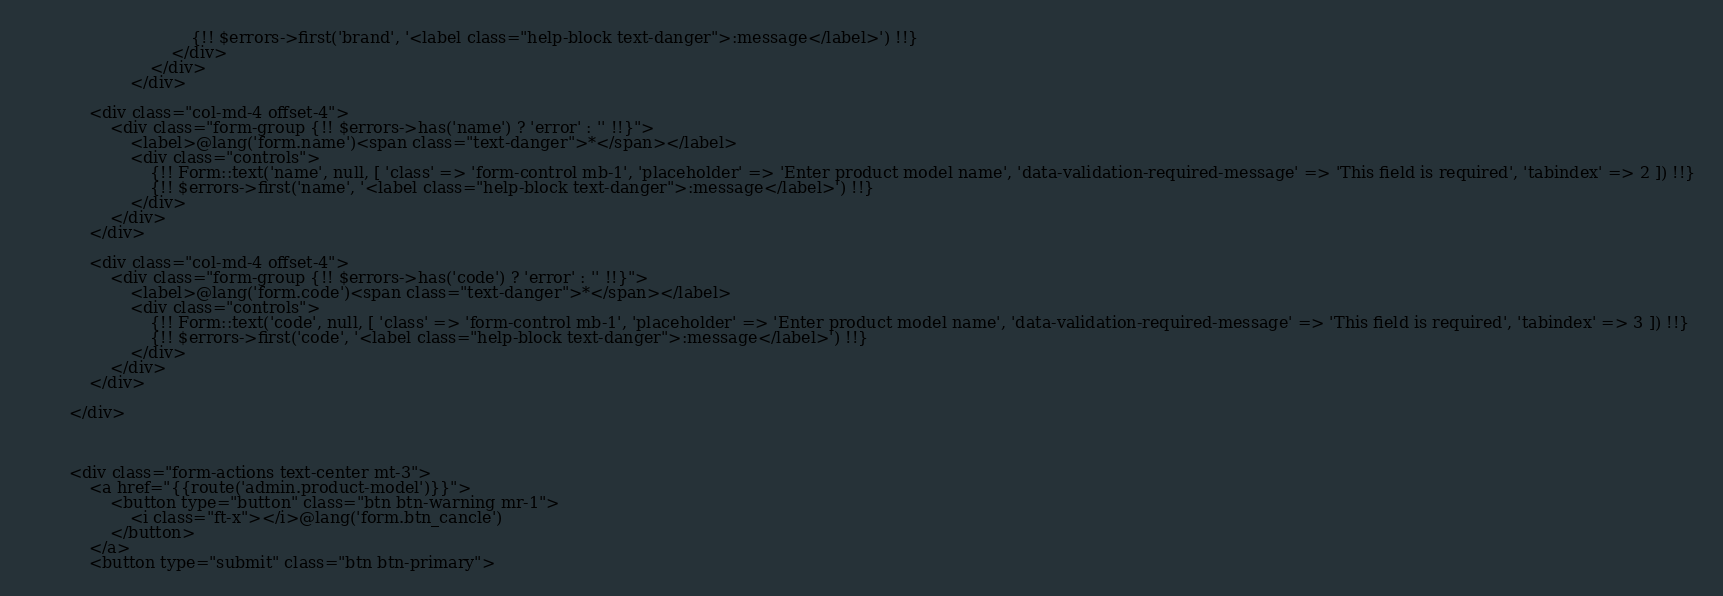Convert code to text. <code><loc_0><loc_0><loc_500><loc_500><_PHP_>                                {!! $errors->first('brand', '<label class="help-block text-danger">:message</label>') !!}
                            </div>
                        </div>
                    </div>

            <div class="col-md-4 offset-4">
                <div class="form-group {!! $errors->has('name') ? 'error' : '' !!}">
                    <label>@lang('form.name')<span class="text-danger">*</span></label>
                    <div class="controls">
                        {!! Form::text('name', null, [ 'class' => 'form-control mb-1', 'placeholder' => 'Enter product model name', 'data-validation-required-message' => 'This field is required', 'tabindex' => 2 ]) !!}
                        {!! $errors->first('name', '<label class="help-block text-danger">:message</label>') !!}
                    </div>
                </div>
            </div>

            <div class="col-md-4 offset-4">
                <div class="form-group {!! $errors->has('code') ? 'error' : '' !!}">
                    <label>@lang('form.code')<span class="text-danger">*</span></label>
                    <div class="controls">
                        {!! Form::text('code', null, [ 'class' => 'form-control mb-1', 'placeholder' => 'Enter product model name', 'data-validation-required-message' => 'This field is required', 'tabindex' => 3 ]) !!}
                        {!! $errors->first('code', '<label class="help-block text-danger">:message</label>') !!}
                    </div>
                </div>
            </div>

        </div>



        <div class="form-actions text-center mt-3">
            <a href="{{route('admin.product-model')}}">
                <button type="button" class="btn btn-warning mr-1">
                    <i class="ft-x"></i>@lang('form.btn_cancle')
                </button>
            </a>
            <button type="submit" class="btn btn-primary"></code> 